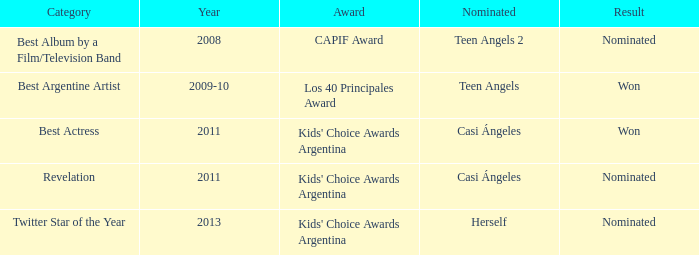Name the performance nominated for a Capif Award. Teen Angels 2. 